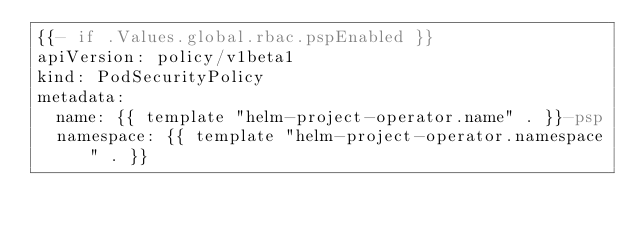Convert code to text. <code><loc_0><loc_0><loc_500><loc_500><_YAML_>{{- if .Values.global.rbac.pspEnabled }}
apiVersion: policy/v1beta1
kind: PodSecurityPolicy
metadata:
  name: {{ template "helm-project-operator.name" . }}-psp
  namespace: {{ template "helm-project-operator.namespace" . }}</code> 